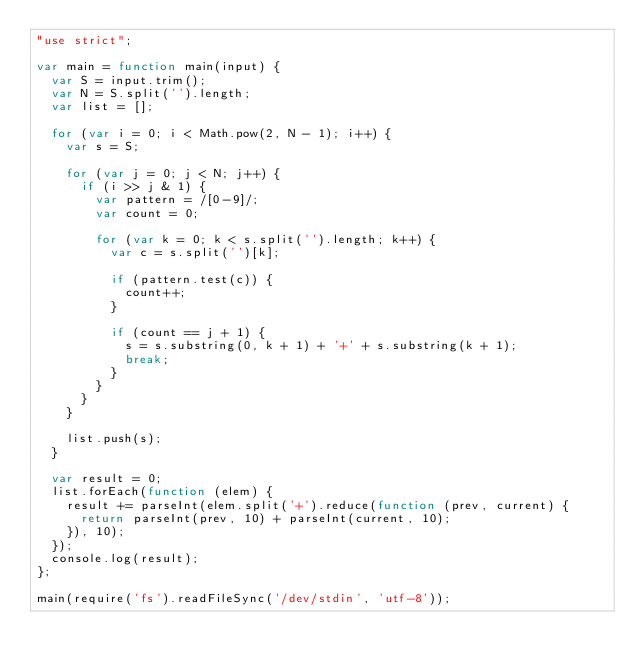<code> <loc_0><loc_0><loc_500><loc_500><_JavaScript_>"use strict";

var main = function main(input) {
  var S = input.trim();
  var N = S.split('').length;
  var list = [];

  for (var i = 0; i < Math.pow(2, N - 1); i++) {
    var s = S;

    for (var j = 0; j < N; j++) {
      if (i >> j & 1) {
        var pattern = /[0-9]/;
        var count = 0;

        for (var k = 0; k < s.split('').length; k++) {
          var c = s.split('')[k];

          if (pattern.test(c)) {
            count++;
          }

          if (count == j + 1) {
            s = s.substring(0, k + 1) + '+' + s.substring(k + 1);
            break;
          }
        }
      }
    }

    list.push(s);
  }

  var result = 0;
  list.forEach(function (elem) {
    result += parseInt(elem.split('+').reduce(function (prev, current) {
      return parseInt(prev, 10) + parseInt(current, 10);
    }), 10);
  });
  console.log(result);
};

main(require('fs').readFileSync('/dev/stdin', 'utf-8'));</code> 